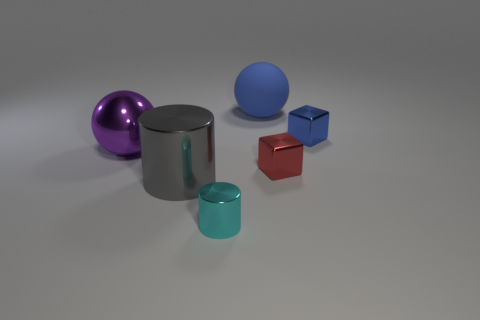Can you describe the lighting setup that may have been used to achieve the shadows and highlights on the objects? The lighting in the image appears to be diffused, possibly from an overhead source, creating soft-edged shadows beneath the objects. The highlights on the objects, particularly on the metallic ones, suggest a large light source or a simulation of an environment map that provides reflections, giving the image a realistic depth and dimensionality. The lack of harsh shadows indicates that the light source is not extremely close to the objects. 